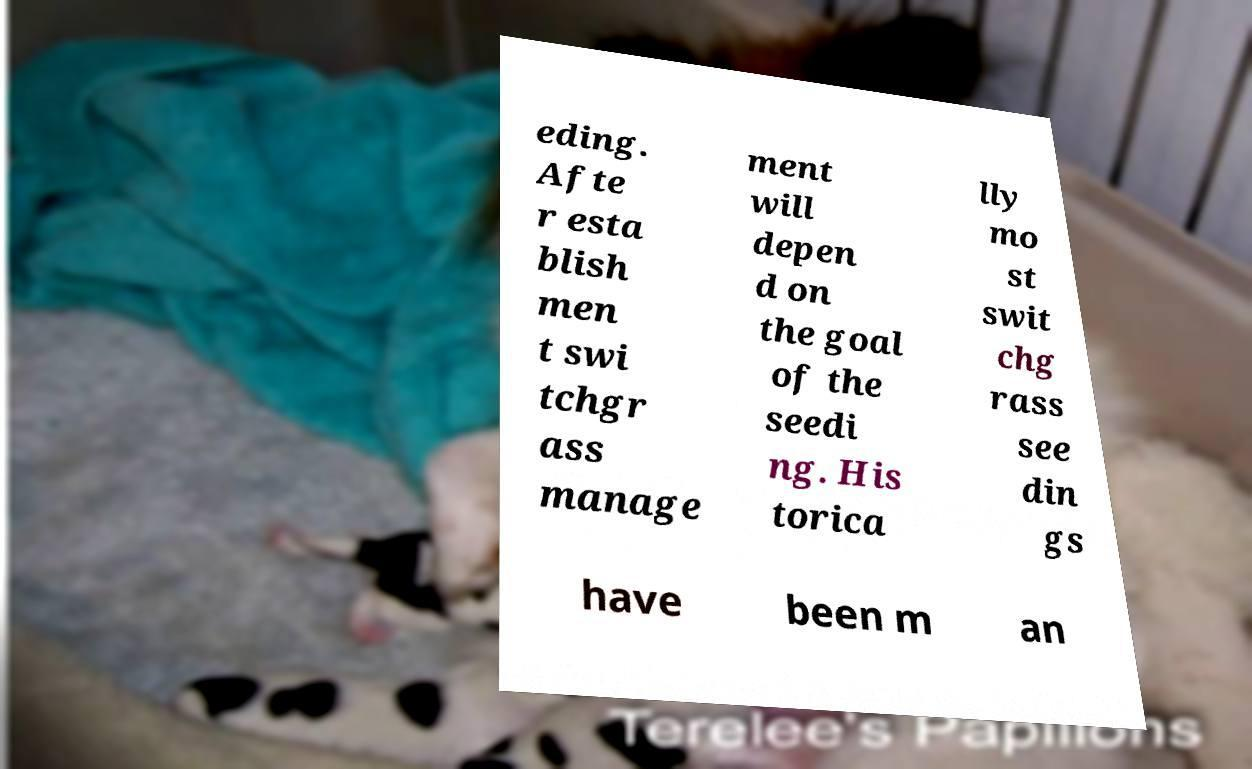Please read and relay the text visible in this image. What does it say? eding. Afte r esta blish men t swi tchgr ass manage ment will depen d on the goal of the seedi ng. His torica lly mo st swit chg rass see din gs have been m an 